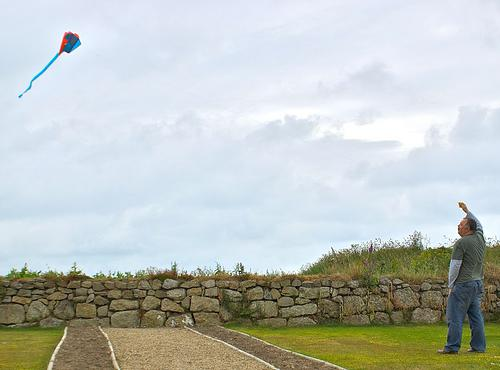Question: what color is the grass?
Choices:
A. Green.
B. Yellow.
C. White.
D. Brown.
Answer with the letter. Answer: A Question: what kind of pants is the man wearing?
Choices:
A. Khaki.
B. Jeans.
C. Dress pants.
D. Tight pants.
Answer with the letter. Answer: B 